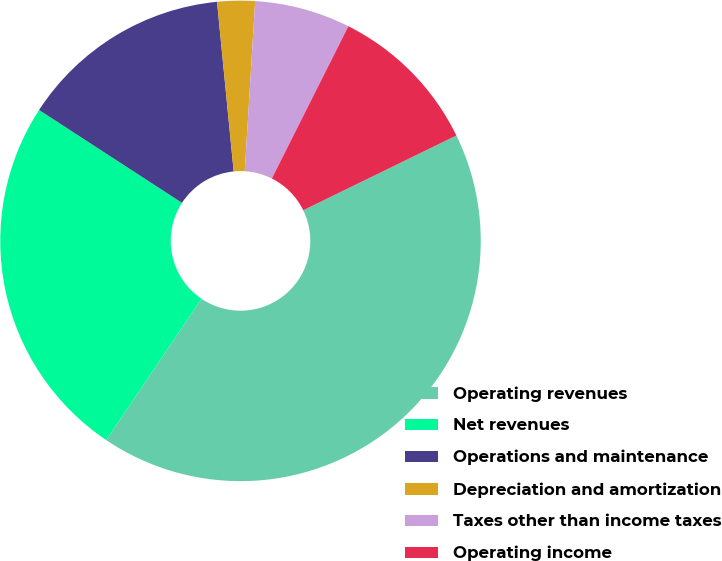Convert chart to OTSL. <chart><loc_0><loc_0><loc_500><loc_500><pie_chart><fcel>Operating revenues<fcel>Net revenues<fcel>Operations and maintenance<fcel>Depreciation and amortization<fcel>Taxes other than income taxes<fcel>Operating income<nl><fcel>41.67%<fcel>24.73%<fcel>14.27%<fcel>2.53%<fcel>6.44%<fcel>10.36%<nl></chart> 